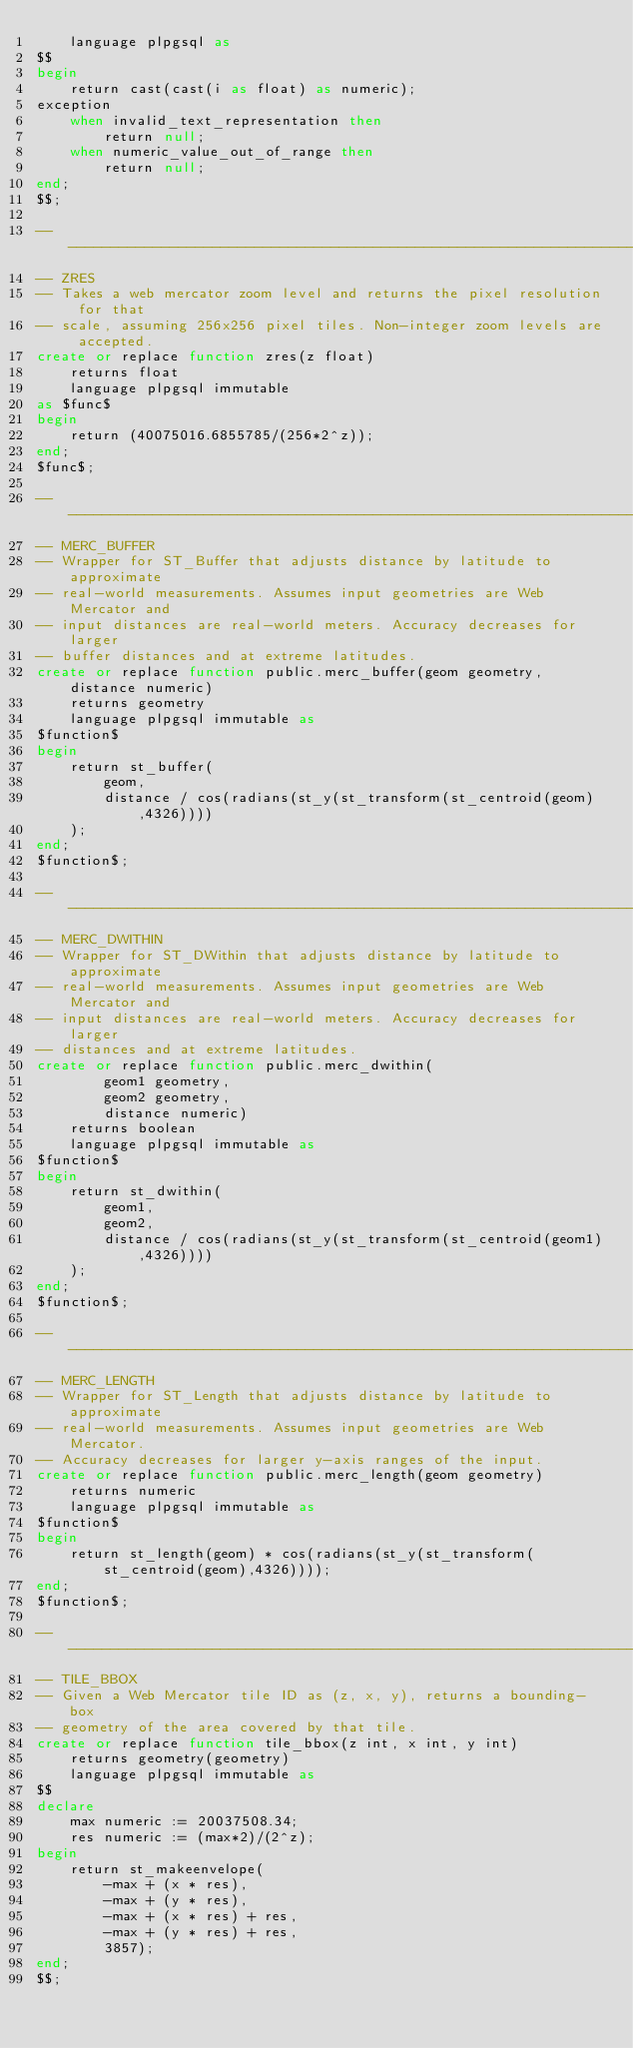<code> <loc_0><loc_0><loc_500><loc_500><_SQL_>    language plpgsql as
$$
begin
    return cast(cast(i as float) as numeric);
exception
    when invalid_text_representation then
        return null;
    when numeric_value_out_of_range then
        return null;
end;
$$;

-- ---------------------------------------------------------------------
-- ZRES
-- Takes a web mercator zoom level and returns the pixel resolution for that
-- scale, assuming 256x256 pixel tiles. Non-integer zoom levels are accepted.
create or replace function zres(z float)
    returns float
    language plpgsql immutable
as $func$
begin
    return (40075016.6855785/(256*2^z));
end;
$func$;

-- ---------------------------------------------------------------------
-- MERC_BUFFER
-- Wrapper for ST_Buffer that adjusts distance by latitude to approximate
-- real-world measurements. Assumes input geometries are Web Mercator and
-- input distances are real-world meters. Accuracy decreases for larger
-- buffer distances and at extreme latitudes.
create or replace function public.merc_buffer(geom geometry, distance numeric)
    returns geometry
    language plpgsql immutable as
$function$
begin
    return st_buffer(
        geom,
        distance / cos(radians(st_y(st_transform(st_centroid(geom),4326))))
    );
end;
$function$;

-- ---------------------------------------------------------------------
-- MERC_DWITHIN
-- Wrapper for ST_DWithin that adjusts distance by latitude to approximate
-- real-world measurements. Assumes input geometries are Web Mercator and
-- input distances are real-world meters. Accuracy decreases for larger
-- distances and at extreme latitudes.
create or replace function public.merc_dwithin(
        geom1 geometry,
        geom2 geometry,
        distance numeric)
    returns boolean
    language plpgsql immutable as
$function$
begin
    return st_dwithin(
        geom1,
        geom2,
        distance / cos(radians(st_y(st_transform(st_centroid(geom1),4326))))
    );
end;
$function$;

-- ---------------------------------------------------------------------
-- MERC_LENGTH
-- Wrapper for ST_Length that adjusts distance by latitude to approximate
-- real-world measurements. Assumes input geometries are Web Mercator.
-- Accuracy decreases for larger y-axis ranges of the input.
create or replace function public.merc_length(geom geometry)
    returns numeric
    language plpgsql immutable as
$function$
begin
    return st_length(geom) * cos(radians(st_y(st_transform(st_centroid(geom),4326))));
end;
$function$;

-- ---------------------------------------------------------------------
-- TILE_BBOX
-- Given a Web Mercator tile ID as (z, x, y), returns a bounding-box
-- geometry of the area covered by that tile.
create or replace function tile_bbox(z int, x int, y int)
    returns geometry(geometry)
    language plpgsql immutable as
$$
declare
    max numeric := 20037508.34;
    res numeric := (max*2)/(2^z);
begin
    return st_makeenvelope(
        -max + (x * res),
        -max + (y * res),
        -max + (x * res) + res,
        -max + (y * res) + res,
        3857);
end;
$$;

</code> 